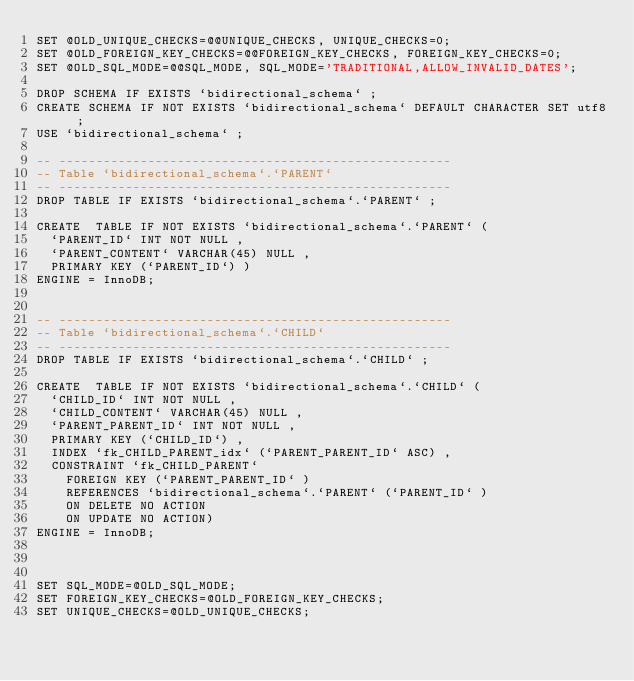Convert code to text. <code><loc_0><loc_0><loc_500><loc_500><_SQL_>SET @OLD_UNIQUE_CHECKS=@@UNIQUE_CHECKS, UNIQUE_CHECKS=0;
SET @OLD_FOREIGN_KEY_CHECKS=@@FOREIGN_KEY_CHECKS, FOREIGN_KEY_CHECKS=0;
SET @OLD_SQL_MODE=@@SQL_MODE, SQL_MODE='TRADITIONAL,ALLOW_INVALID_DATES';

DROP SCHEMA IF EXISTS `bidirectional_schema` ;
CREATE SCHEMA IF NOT EXISTS `bidirectional_schema` DEFAULT CHARACTER SET utf8 ;
USE `bidirectional_schema` ;

-- -----------------------------------------------------
-- Table `bidirectional_schema`.`PARENT`
-- -----------------------------------------------------
DROP TABLE IF EXISTS `bidirectional_schema`.`PARENT` ;

CREATE  TABLE IF NOT EXISTS `bidirectional_schema`.`PARENT` (
  `PARENT_ID` INT NOT NULL ,
  `PARENT_CONTENT` VARCHAR(45) NULL ,
  PRIMARY KEY (`PARENT_ID`) )
ENGINE = InnoDB;


-- -----------------------------------------------------
-- Table `bidirectional_schema`.`CHILD`
-- -----------------------------------------------------
DROP TABLE IF EXISTS `bidirectional_schema`.`CHILD` ;

CREATE  TABLE IF NOT EXISTS `bidirectional_schema`.`CHILD` (
  `CHILD_ID` INT NOT NULL ,
  `CHILD_CONTENT` VARCHAR(45) NULL ,
  `PARENT_PARENT_ID` INT NOT NULL ,
  PRIMARY KEY (`CHILD_ID`) ,
  INDEX `fk_CHILD_PARENT_idx` (`PARENT_PARENT_ID` ASC) ,
  CONSTRAINT `fk_CHILD_PARENT`
    FOREIGN KEY (`PARENT_PARENT_ID` )
    REFERENCES `bidirectional_schema`.`PARENT` (`PARENT_ID` )
    ON DELETE NO ACTION
    ON UPDATE NO ACTION)
ENGINE = InnoDB;



SET SQL_MODE=@OLD_SQL_MODE;
SET FOREIGN_KEY_CHECKS=@OLD_FOREIGN_KEY_CHECKS;
SET UNIQUE_CHECKS=@OLD_UNIQUE_CHECKS;
</code> 